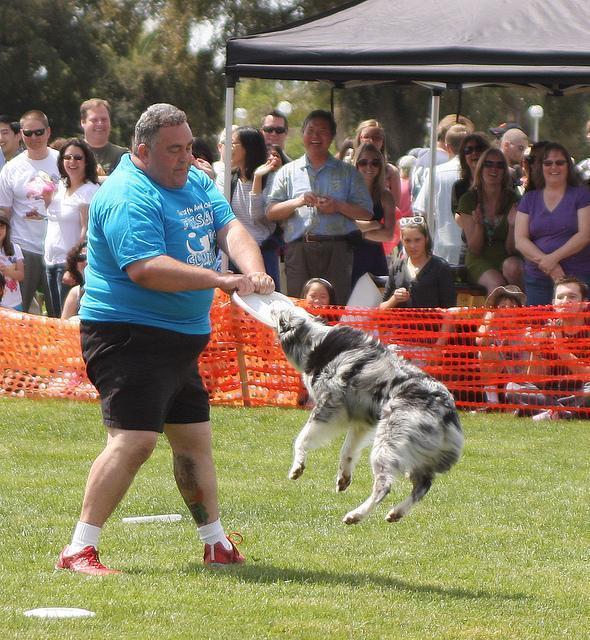How many people are there?
Give a very brief answer. 11. How many airplane wheels are to be seen?
Give a very brief answer. 0. 